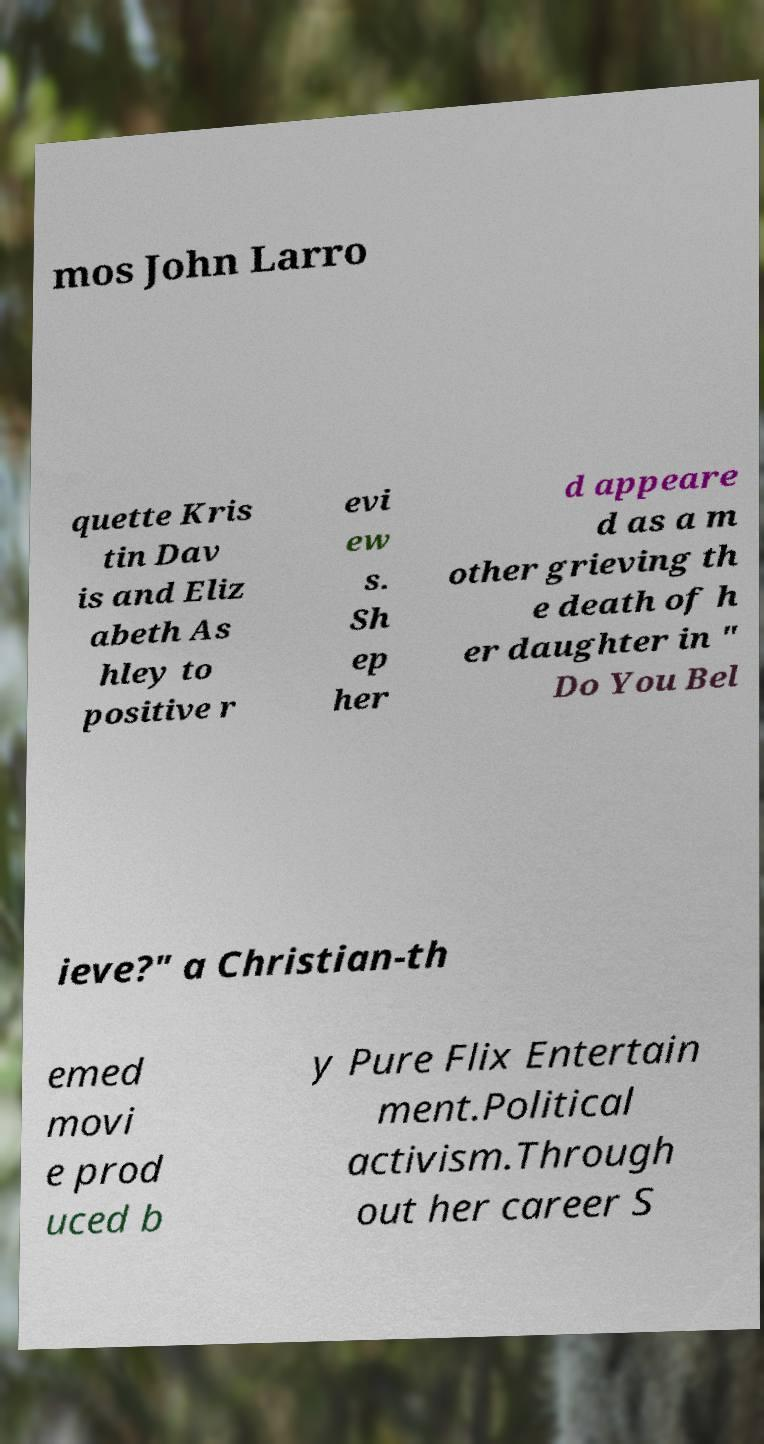There's text embedded in this image that I need extracted. Can you transcribe it verbatim? mos John Larro quette Kris tin Dav is and Eliz abeth As hley to positive r evi ew s. Sh ep her d appeare d as a m other grieving th e death of h er daughter in " Do You Bel ieve?" a Christian-th emed movi e prod uced b y Pure Flix Entertain ment.Political activism.Through out her career S 